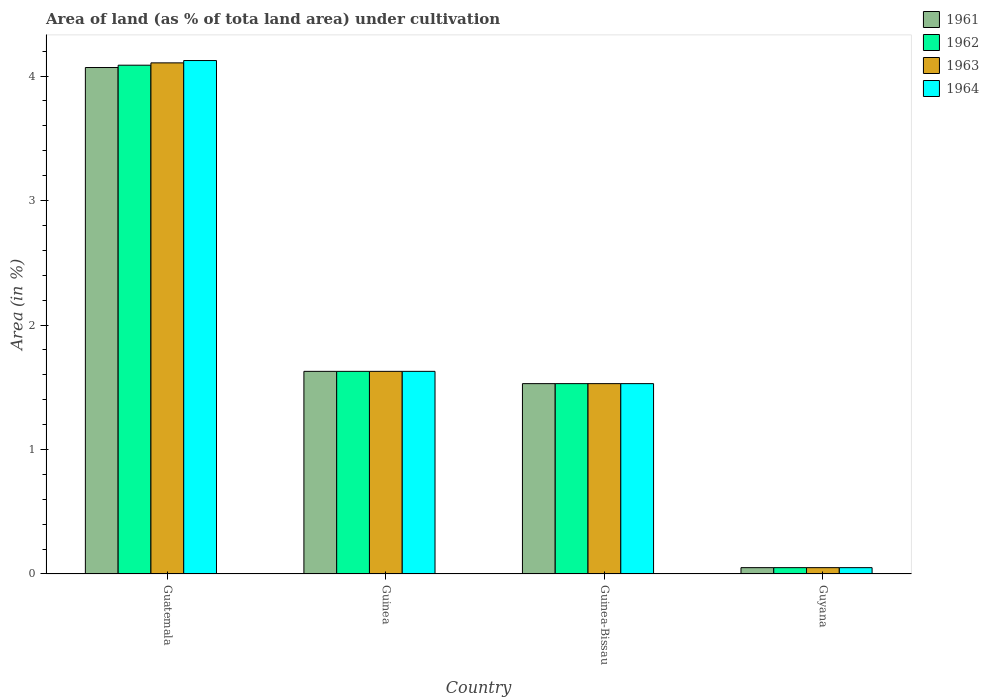How many different coloured bars are there?
Give a very brief answer. 4. How many groups of bars are there?
Give a very brief answer. 4. How many bars are there on the 3rd tick from the left?
Your answer should be compact. 4. How many bars are there on the 3rd tick from the right?
Your response must be concise. 4. What is the label of the 2nd group of bars from the left?
Keep it short and to the point. Guinea. What is the percentage of land under cultivation in 1963 in Guinea?
Make the answer very short. 1.63. Across all countries, what is the maximum percentage of land under cultivation in 1963?
Ensure brevity in your answer.  4.11. Across all countries, what is the minimum percentage of land under cultivation in 1961?
Your response must be concise. 0.05. In which country was the percentage of land under cultivation in 1961 maximum?
Make the answer very short. Guatemala. In which country was the percentage of land under cultivation in 1962 minimum?
Provide a succinct answer. Guyana. What is the total percentage of land under cultivation in 1964 in the graph?
Provide a short and direct response. 7.33. What is the difference between the percentage of land under cultivation in 1961 in Guinea and that in Guinea-Bissau?
Ensure brevity in your answer.  0.1. What is the difference between the percentage of land under cultivation in 1962 in Guatemala and the percentage of land under cultivation in 1961 in Guinea-Bissau?
Your response must be concise. 2.56. What is the average percentage of land under cultivation in 1963 per country?
Ensure brevity in your answer.  1.83. In how many countries, is the percentage of land under cultivation in 1962 greater than 1 %?
Provide a succinct answer. 3. What is the ratio of the percentage of land under cultivation in 1963 in Guinea to that in Guinea-Bissau?
Provide a short and direct response. 1.06. Is the difference between the percentage of land under cultivation in 1961 in Guinea and Guyana greater than the difference between the percentage of land under cultivation in 1964 in Guinea and Guyana?
Your response must be concise. No. What is the difference between the highest and the second highest percentage of land under cultivation in 1962?
Provide a succinct answer. -2.46. What is the difference between the highest and the lowest percentage of land under cultivation in 1963?
Provide a short and direct response. 4.06. Is it the case that in every country, the sum of the percentage of land under cultivation in 1961 and percentage of land under cultivation in 1963 is greater than the percentage of land under cultivation in 1962?
Provide a succinct answer. Yes. Are all the bars in the graph horizontal?
Your answer should be compact. No. What is the difference between two consecutive major ticks on the Y-axis?
Your response must be concise. 1. Are the values on the major ticks of Y-axis written in scientific E-notation?
Ensure brevity in your answer.  No. Does the graph contain any zero values?
Provide a succinct answer. No. Does the graph contain grids?
Offer a terse response. No. How many legend labels are there?
Give a very brief answer. 4. How are the legend labels stacked?
Give a very brief answer. Vertical. What is the title of the graph?
Your answer should be compact. Area of land (as % of tota land area) under cultivation. What is the label or title of the Y-axis?
Make the answer very short. Area (in %). What is the Area (in %) of 1961 in Guatemala?
Your answer should be very brief. 4.07. What is the Area (in %) in 1962 in Guatemala?
Your answer should be very brief. 4.09. What is the Area (in %) of 1963 in Guatemala?
Make the answer very short. 4.11. What is the Area (in %) in 1964 in Guatemala?
Your answer should be compact. 4.12. What is the Area (in %) of 1961 in Guinea?
Your answer should be very brief. 1.63. What is the Area (in %) in 1962 in Guinea?
Keep it short and to the point. 1.63. What is the Area (in %) of 1963 in Guinea?
Your answer should be very brief. 1.63. What is the Area (in %) of 1964 in Guinea?
Your answer should be compact. 1.63. What is the Area (in %) in 1961 in Guinea-Bissau?
Give a very brief answer. 1.53. What is the Area (in %) in 1962 in Guinea-Bissau?
Your response must be concise. 1.53. What is the Area (in %) of 1963 in Guinea-Bissau?
Your answer should be very brief. 1.53. What is the Area (in %) of 1964 in Guinea-Bissau?
Provide a succinct answer. 1.53. What is the Area (in %) of 1961 in Guyana?
Your answer should be compact. 0.05. What is the Area (in %) in 1962 in Guyana?
Your response must be concise. 0.05. What is the Area (in %) of 1963 in Guyana?
Provide a short and direct response. 0.05. What is the Area (in %) in 1964 in Guyana?
Your answer should be compact. 0.05. Across all countries, what is the maximum Area (in %) in 1961?
Offer a very short reply. 4.07. Across all countries, what is the maximum Area (in %) in 1962?
Provide a succinct answer. 4.09. Across all countries, what is the maximum Area (in %) in 1963?
Ensure brevity in your answer.  4.11. Across all countries, what is the maximum Area (in %) in 1964?
Ensure brevity in your answer.  4.12. Across all countries, what is the minimum Area (in %) of 1961?
Offer a very short reply. 0.05. Across all countries, what is the minimum Area (in %) of 1962?
Your response must be concise. 0.05. Across all countries, what is the minimum Area (in %) in 1963?
Keep it short and to the point. 0.05. Across all countries, what is the minimum Area (in %) of 1964?
Offer a very short reply. 0.05. What is the total Area (in %) of 1961 in the graph?
Provide a succinct answer. 7.28. What is the total Area (in %) in 1962 in the graph?
Your answer should be very brief. 7.3. What is the total Area (in %) of 1963 in the graph?
Your answer should be compact. 7.31. What is the total Area (in %) in 1964 in the graph?
Provide a succinct answer. 7.33. What is the difference between the Area (in %) in 1961 in Guatemala and that in Guinea?
Ensure brevity in your answer.  2.44. What is the difference between the Area (in %) in 1962 in Guatemala and that in Guinea?
Keep it short and to the point. 2.46. What is the difference between the Area (in %) in 1963 in Guatemala and that in Guinea?
Provide a succinct answer. 2.48. What is the difference between the Area (in %) in 1964 in Guatemala and that in Guinea?
Give a very brief answer. 2.5. What is the difference between the Area (in %) of 1961 in Guatemala and that in Guinea-Bissau?
Keep it short and to the point. 2.54. What is the difference between the Area (in %) of 1962 in Guatemala and that in Guinea-Bissau?
Offer a very short reply. 2.56. What is the difference between the Area (in %) of 1963 in Guatemala and that in Guinea-Bissau?
Provide a short and direct response. 2.58. What is the difference between the Area (in %) of 1964 in Guatemala and that in Guinea-Bissau?
Provide a short and direct response. 2.6. What is the difference between the Area (in %) in 1961 in Guatemala and that in Guyana?
Give a very brief answer. 4.02. What is the difference between the Area (in %) of 1962 in Guatemala and that in Guyana?
Your response must be concise. 4.04. What is the difference between the Area (in %) in 1963 in Guatemala and that in Guyana?
Your answer should be compact. 4.06. What is the difference between the Area (in %) of 1964 in Guatemala and that in Guyana?
Provide a short and direct response. 4.07. What is the difference between the Area (in %) of 1961 in Guinea and that in Guinea-Bissau?
Provide a succinct answer. 0.1. What is the difference between the Area (in %) of 1962 in Guinea and that in Guinea-Bissau?
Offer a very short reply. 0.1. What is the difference between the Area (in %) of 1963 in Guinea and that in Guinea-Bissau?
Offer a very short reply. 0.1. What is the difference between the Area (in %) of 1964 in Guinea and that in Guinea-Bissau?
Give a very brief answer. 0.1. What is the difference between the Area (in %) in 1961 in Guinea and that in Guyana?
Your response must be concise. 1.58. What is the difference between the Area (in %) of 1962 in Guinea and that in Guyana?
Keep it short and to the point. 1.58. What is the difference between the Area (in %) in 1963 in Guinea and that in Guyana?
Ensure brevity in your answer.  1.58. What is the difference between the Area (in %) of 1964 in Guinea and that in Guyana?
Offer a very short reply. 1.58. What is the difference between the Area (in %) of 1961 in Guinea-Bissau and that in Guyana?
Offer a terse response. 1.48. What is the difference between the Area (in %) in 1962 in Guinea-Bissau and that in Guyana?
Ensure brevity in your answer.  1.48. What is the difference between the Area (in %) of 1963 in Guinea-Bissau and that in Guyana?
Your answer should be very brief. 1.48. What is the difference between the Area (in %) of 1964 in Guinea-Bissau and that in Guyana?
Your answer should be very brief. 1.48. What is the difference between the Area (in %) in 1961 in Guatemala and the Area (in %) in 1962 in Guinea?
Keep it short and to the point. 2.44. What is the difference between the Area (in %) in 1961 in Guatemala and the Area (in %) in 1963 in Guinea?
Your answer should be very brief. 2.44. What is the difference between the Area (in %) in 1961 in Guatemala and the Area (in %) in 1964 in Guinea?
Give a very brief answer. 2.44. What is the difference between the Area (in %) in 1962 in Guatemala and the Area (in %) in 1963 in Guinea?
Your answer should be compact. 2.46. What is the difference between the Area (in %) of 1962 in Guatemala and the Area (in %) of 1964 in Guinea?
Offer a terse response. 2.46. What is the difference between the Area (in %) of 1963 in Guatemala and the Area (in %) of 1964 in Guinea?
Make the answer very short. 2.48. What is the difference between the Area (in %) in 1961 in Guatemala and the Area (in %) in 1962 in Guinea-Bissau?
Your response must be concise. 2.54. What is the difference between the Area (in %) in 1961 in Guatemala and the Area (in %) in 1963 in Guinea-Bissau?
Provide a succinct answer. 2.54. What is the difference between the Area (in %) in 1961 in Guatemala and the Area (in %) in 1964 in Guinea-Bissau?
Your answer should be compact. 2.54. What is the difference between the Area (in %) in 1962 in Guatemala and the Area (in %) in 1963 in Guinea-Bissau?
Give a very brief answer. 2.56. What is the difference between the Area (in %) of 1962 in Guatemala and the Area (in %) of 1964 in Guinea-Bissau?
Your answer should be very brief. 2.56. What is the difference between the Area (in %) in 1963 in Guatemala and the Area (in %) in 1964 in Guinea-Bissau?
Offer a terse response. 2.58. What is the difference between the Area (in %) in 1961 in Guatemala and the Area (in %) in 1962 in Guyana?
Make the answer very short. 4.02. What is the difference between the Area (in %) in 1961 in Guatemala and the Area (in %) in 1963 in Guyana?
Provide a succinct answer. 4.02. What is the difference between the Area (in %) of 1961 in Guatemala and the Area (in %) of 1964 in Guyana?
Provide a short and direct response. 4.02. What is the difference between the Area (in %) in 1962 in Guatemala and the Area (in %) in 1963 in Guyana?
Ensure brevity in your answer.  4.04. What is the difference between the Area (in %) in 1962 in Guatemala and the Area (in %) in 1964 in Guyana?
Keep it short and to the point. 4.04. What is the difference between the Area (in %) in 1963 in Guatemala and the Area (in %) in 1964 in Guyana?
Your answer should be very brief. 4.06. What is the difference between the Area (in %) of 1961 in Guinea and the Area (in %) of 1962 in Guinea-Bissau?
Make the answer very short. 0.1. What is the difference between the Area (in %) in 1961 in Guinea and the Area (in %) in 1963 in Guinea-Bissau?
Ensure brevity in your answer.  0.1. What is the difference between the Area (in %) in 1961 in Guinea and the Area (in %) in 1964 in Guinea-Bissau?
Provide a short and direct response. 0.1. What is the difference between the Area (in %) in 1962 in Guinea and the Area (in %) in 1963 in Guinea-Bissau?
Your response must be concise. 0.1. What is the difference between the Area (in %) in 1962 in Guinea and the Area (in %) in 1964 in Guinea-Bissau?
Your response must be concise. 0.1. What is the difference between the Area (in %) of 1963 in Guinea and the Area (in %) of 1964 in Guinea-Bissau?
Your answer should be compact. 0.1. What is the difference between the Area (in %) in 1961 in Guinea and the Area (in %) in 1962 in Guyana?
Keep it short and to the point. 1.58. What is the difference between the Area (in %) of 1961 in Guinea and the Area (in %) of 1963 in Guyana?
Keep it short and to the point. 1.58. What is the difference between the Area (in %) in 1961 in Guinea and the Area (in %) in 1964 in Guyana?
Offer a very short reply. 1.58. What is the difference between the Area (in %) in 1962 in Guinea and the Area (in %) in 1963 in Guyana?
Your answer should be compact. 1.58. What is the difference between the Area (in %) of 1962 in Guinea and the Area (in %) of 1964 in Guyana?
Your answer should be compact. 1.58. What is the difference between the Area (in %) of 1963 in Guinea and the Area (in %) of 1964 in Guyana?
Provide a short and direct response. 1.58. What is the difference between the Area (in %) of 1961 in Guinea-Bissau and the Area (in %) of 1962 in Guyana?
Make the answer very short. 1.48. What is the difference between the Area (in %) in 1961 in Guinea-Bissau and the Area (in %) in 1963 in Guyana?
Provide a succinct answer. 1.48. What is the difference between the Area (in %) of 1961 in Guinea-Bissau and the Area (in %) of 1964 in Guyana?
Your answer should be compact. 1.48. What is the difference between the Area (in %) in 1962 in Guinea-Bissau and the Area (in %) in 1963 in Guyana?
Give a very brief answer. 1.48. What is the difference between the Area (in %) of 1962 in Guinea-Bissau and the Area (in %) of 1964 in Guyana?
Provide a short and direct response. 1.48. What is the difference between the Area (in %) of 1963 in Guinea-Bissau and the Area (in %) of 1964 in Guyana?
Give a very brief answer. 1.48. What is the average Area (in %) of 1961 per country?
Provide a succinct answer. 1.82. What is the average Area (in %) in 1962 per country?
Your response must be concise. 1.82. What is the average Area (in %) in 1963 per country?
Offer a very short reply. 1.83. What is the average Area (in %) in 1964 per country?
Make the answer very short. 1.83. What is the difference between the Area (in %) of 1961 and Area (in %) of 1962 in Guatemala?
Your answer should be very brief. -0.02. What is the difference between the Area (in %) of 1961 and Area (in %) of 1963 in Guatemala?
Make the answer very short. -0.04. What is the difference between the Area (in %) in 1961 and Area (in %) in 1964 in Guatemala?
Provide a short and direct response. -0.06. What is the difference between the Area (in %) in 1962 and Area (in %) in 1963 in Guatemala?
Your answer should be very brief. -0.02. What is the difference between the Area (in %) of 1962 and Area (in %) of 1964 in Guatemala?
Keep it short and to the point. -0.04. What is the difference between the Area (in %) in 1963 and Area (in %) in 1964 in Guatemala?
Make the answer very short. -0.02. What is the difference between the Area (in %) of 1961 and Area (in %) of 1964 in Guinea?
Make the answer very short. 0. What is the difference between the Area (in %) of 1962 and Area (in %) of 1963 in Guinea?
Ensure brevity in your answer.  0. What is the difference between the Area (in %) in 1963 and Area (in %) in 1964 in Guinea?
Keep it short and to the point. 0. What is the difference between the Area (in %) in 1961 and Area (in %) in 1962 in Guinea-Bissau?
Your answer should be very brief. 0. What is the difference between the Area (in %) in 1962 and Area (in %) in 1964 in Guinea-Bissau?
Ensure brevity in your answer.  0. What is the difference between the Area (in %) of 1961 and Area (in %) of 1962 in Guyana?
Give a very brief answer. 0. What is the difference between the Area (in %) in 1961 and Area (in %) in 1963 in Guyana?
Give a very brief answer. 0. What is the difference between the Area (in %) in 1961 and Area (in %) in 1964 in Guyana?
Your answer should be compact. 0. What is the difference between the Area (in %) in 1962 and Area (in %) in 1964 in Guyana?
Keep it short and to the point. 0. What is the ratio of the Area (in %) in 1961 in Guatemala to that in Guinea?
Ensure brevity in your answer.  2.5. What is the ratio of the Area (in %) of 1962 in Guatemala to that in Guinea?
Your answer should be compact. 2.51. What is the ratio of the Area (in %) in 1963 in Guatemala to that in Guinea?
Your response must be concise. 2.52. What is the ratio of the Area (in %) of 1964 in Guatemala to that in Guinea?
Provide a succinct answer. 2.53. What is the ratio of the Area (in %) in 1961 in Guatemala to that in Guinea-Bissau?
Your answer should be very brief. 2.66. What is the ratio of the Area (in %) in 1962 in Guatemala to that in Guinea-Bissau?
Keep it short and to the point. 2.67. What is the ratio of the Area (in %) of 1963 in Guatemala to that in Guinea-Bissau?
Keep it short and to the point. 2.69. What is the ratio of the Area (in %) of 1964 in Guatemala to that in Guinea-Bissau?
Your answer should be very brief. 2.7. What is the ratio of the Area (in %) in 1961 in Guatemala to that in Guyana?
Give a very brief answer. 80.04. What is the ratio of the Area (in %) in 1962 in Guatemala to that in Guyana?
Offer a terse response. 80.4. What is the ratio of the Area (in %) in 1963 in Guatemala to that in Guyana?
Your answer should be very brief. 80.77. What is the ratio of the Area (in %) of 1964 in Guatemala to that in Guyana?
Make the answer very short. 81.14. What is the ratio of the Area (in %) in 1961 in Guinea to that in Guinea-Bissau?
Give a very brief answer. 1.06. What is the ratio of the Area (in %) in 1962 in Guinea to that in Guinea-Bissau?
Offer a terse response. 1.06. What is the ratio of the Area (in %) in 1963 in Guinea to that in Guinea-Bissau?
Your answer should be compact. 1.06. What is the ratio of the Area (in %) in 1964 in Guinea to that in Guinea-Bissau?
Your answer should be very brief. 1.06. What is the ratio of the Area (in %) in 1961 in Guinea to that in Guyana?
Offer a very short reply. 32.02. What is the ratio of the Area (in %) of 1962 in Guinea to that in Guyana?
Make the answer very short. 32.02. What is the ratio of the Area (in %) of 1963 in Guinea to that in Guyana?
Offer a very short reply. 32.02. What is the ratio of the Area (in %) of 1964 in Guinea to that in Guyana?
Offer a very short reply. 32.02. What is the ratio of the Area (in %) of 1961 in Guinea-Bissau to that in Guyana?
Make the answer very short. 30.08. What is the ratio of the Area (in %) of 1962 in Guinea-Bissau to that in Guyana?
Your answer should be compact. 30.08. What is the ratio of the Area (in %) in 1963 in Guinea-Bissau to that in Guyana?
Your answer should be very brief. 30.08. What is the ratio of the Area (in %) of 1964 in Guinea-Bissau to that in Guyana?
Your answer should be very brief. 30.08. What is the difference between the highest and the second highest Area (in %) of 1961?
Your response must be concise. 2.44. What is the difference between the highest and the second highest Area (in %) in 1962?
Offer a very short reply. 2.46. What is the difference between the highest and the second highest Area (in %) of 1963?
Your answer should be very brief. 2.48. What is the difference between the highest and the second highest Area (in %) in 1964?
Provide a short and direct response. 2.5. What is the difference between the highest and the lowest Area (in %) in 1961?
Offer a very short reply. 4.02. What is the difference between the highest and the lowest Area (in %) of 1962?
Offer a very short reply. 4.04. What is the difference between the highest and the lowest Area (in %) in 1963?
Provide a short and direct response. 4.06. What is the difference between the highest and the lowest Area (in %) of 1964?
Provide a short and direct response. 4.07. 